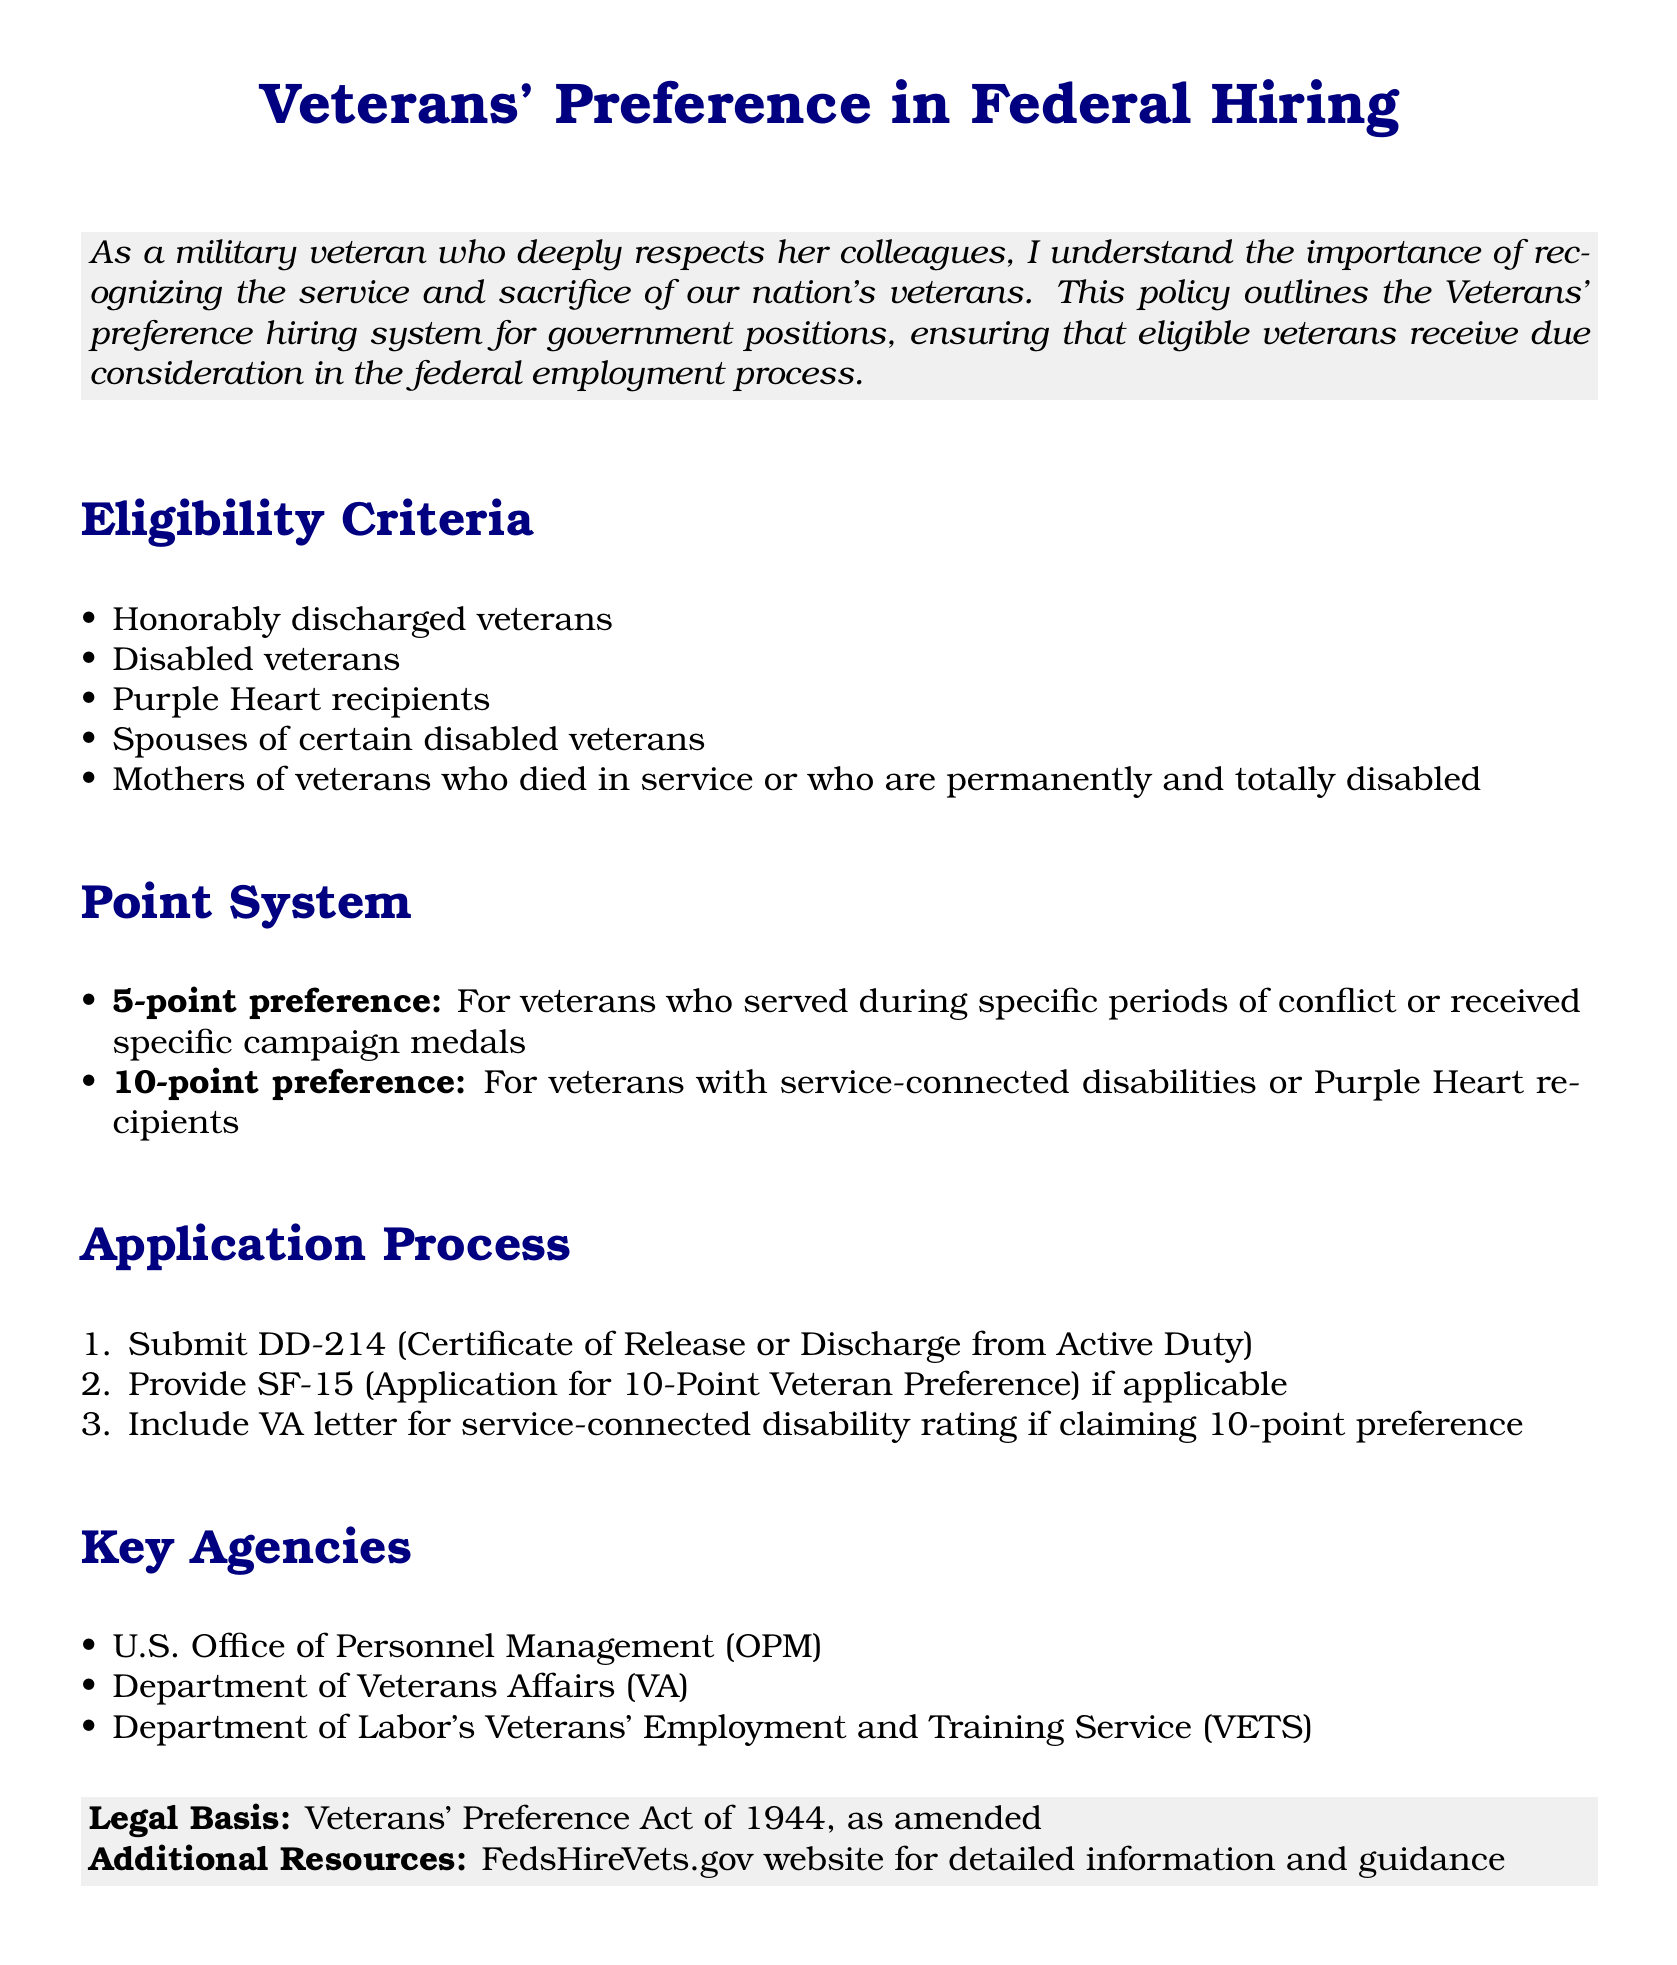What is the eligibility criteria for Veterans' preference? The eligibility criteria are outlined in the document, which includes honorably discharged veterans, disabled veterans, Purple Heart recipients, spouses of certain disabled veterans, and mothers of veterans who died in service or who are permanently and totally disabled.
Answer: Honorably discharged veterans, disabled veterans, Purple Heart recipients, spouses of certain disabled veterans, mothers of veterans who died in service or who are permanently and totally disabled What is the point preference for veterans with service-connected disabilities? The document specifies a point preference system for veterans. A 10-point preference is awarded to veterans with service-connected disabilities.
Answer: 10-point preference Which agency is mentioned as responsible for Veterans' employment and training? The document lists key agencies involved in veterans' employment, including the Department of Labor's Veterans' Employment and Training Service.
Answer: Department of Labor's Veterans' Employment and Training Service What document must be submitted to claim Veterans' preference? According to the application process in the document, veterans must submit the DD-214 to claim their preference.
Answer: DD-214 How many points are awarded for serving during specific periods of conflict? The specifics of the point system in the document indicate that a veteran would receive a 5-point preference for serving during specific periods of conflict.
Answer: 5-point preference Who can claim a 10-point preference based on the document? The document states that veterans with service-connected disabilities or Purple Heart recipients can claim a 10-point preference.
Answer: Veterans with service-connected disabilities or Purple Heart recipients What is the legal basis for the Veterans' preference policy? The document cites the legal basis for the policy as the Veterans' Preference Act of 1944, as amended.
Answer: Veterans' Preference Act of 1944 What application form is required for 10-point Veteran Preference? The document mentions the SF-15 as the required application form for veterans claiming 10-point preference.
Answer: SF-15 What is the title of the document? The title is prominently displayed at the beginning of the document, highlighting the focus on Veterans' preference in federal hiring.
Answer: Veterans' Preference in Federal Hiring 